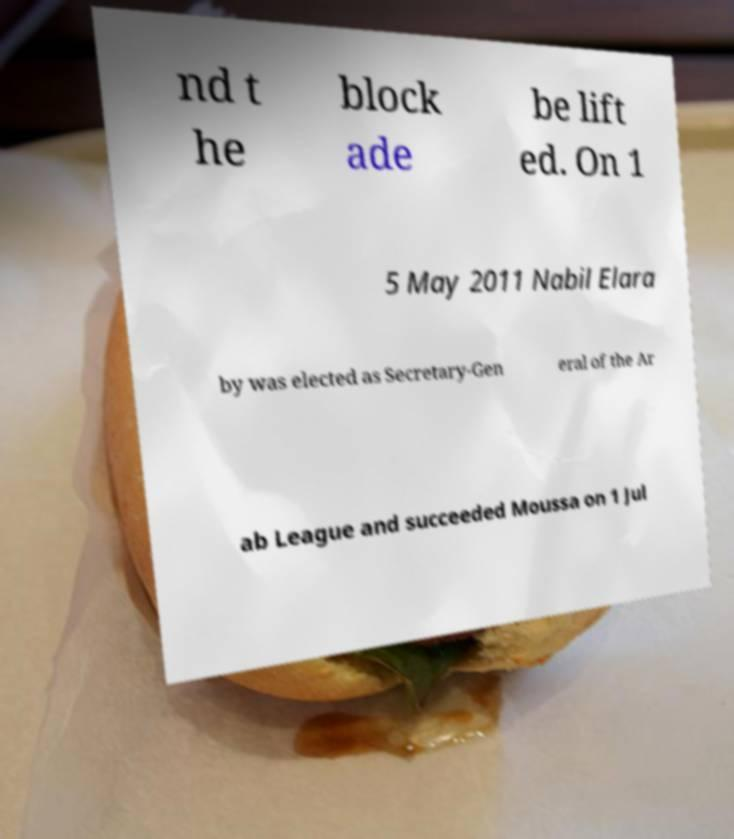Please read and relay the text visible in this image. What does it say? nd t he block ade be lift ed. On 1 5 May 2011 Nabil Elara by was elected as Secretary-Gen eral of the Ar ab League and succeeded Moussa on 1 Jul 